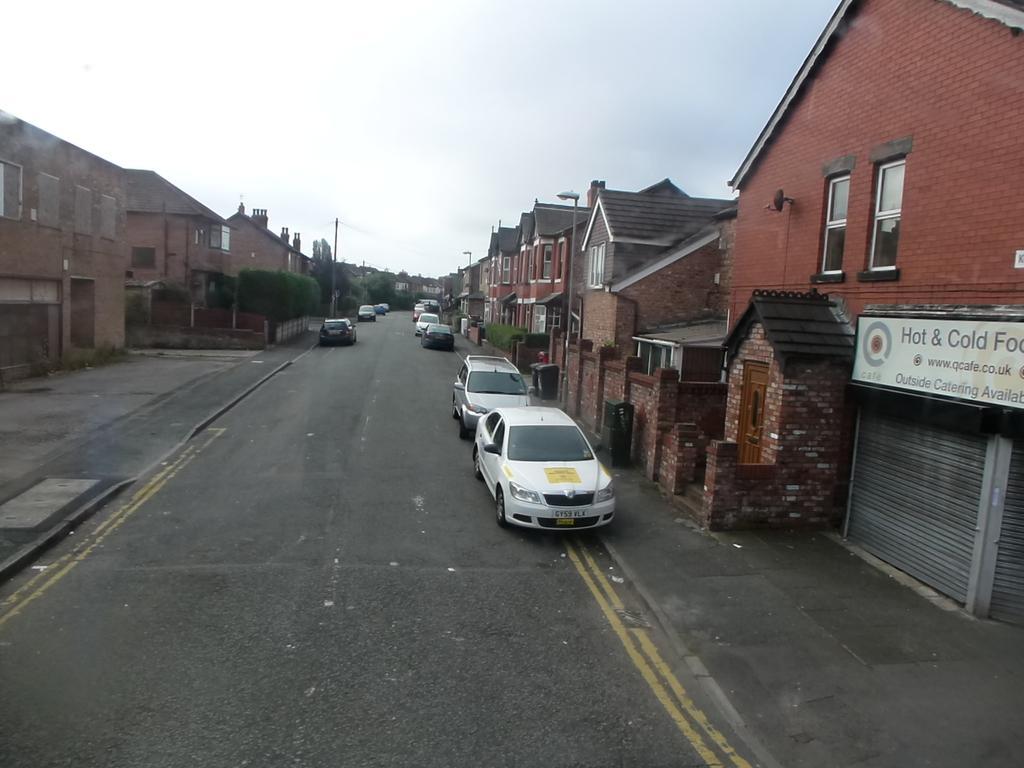How would you summarize this image in a sentence or two? In this image I can see vehicles on the road. Here I can see buildings, street lights and a board on which something written on it. In the background I can see the sky. 